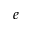Convert formula to latex. <formula><loc_0><loc_0><loc_500><loc_500>e</formula> 